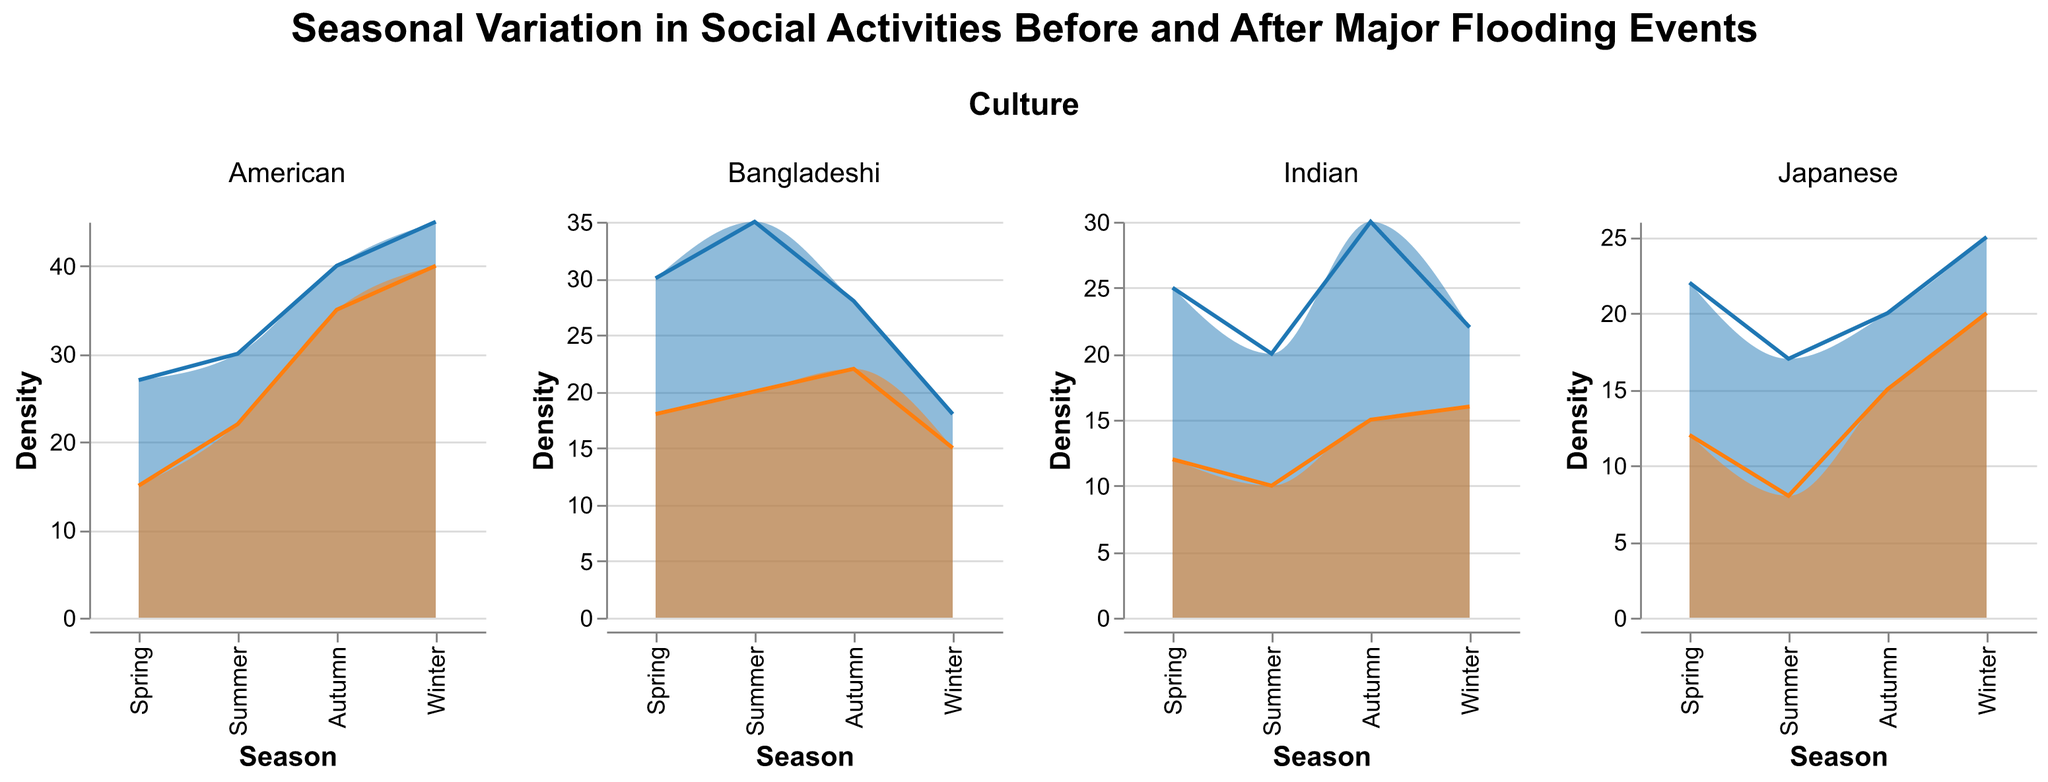What is the title of the figure? The title is displayed at the top of the figure in large font. It reads "Seasonal Variation in Social Activities Before and After Major Flooding Events"
Answer: Seasonal Variation in Social Activities Before and After Major Flooding Events How many cultures are analyzed in the figure? The figure is divided into columns, each representing a different culture. There are four columns: Japanese, Bangladeshi, American, and Indian
Answer: Four What are the colors used to represent the pre-flood and post-flood activities? The density plots use two distinct colors: blue for pre-flood activities and orange for post-flood activities
Answer: Blue and orange Which season had the highest pre-flood activity for the American culture? By viewing the density lines for seasonal activities in the American culture, we can see that the highest pre-flood activity occurs in winter for Christmas
Answer: Winter What is the difference in post-flood density between the Japanese and Bangladeshi cultures for their spring activities? For spring activities, the post-flood densities are 12 for Japanese and 18 for Bangladeshi. The difference is 18 - 12
Answer: 6 In which season did the Indian culture experience the least decrease in activity post-flood compared to pre-flood? By comparing pre-flood and post-flood densities across seasons for the Indian culture, the smallest decrease is observed in Winter from 22 to 16
Answer: Winter What is the average pre-flood density of activities for the Japanese culture in spring and summer? The pre-flood densities for spring and summer for the Japanese culture are 22 and 17. The average is (22 + 17) / 2
Answer: 19.5 Which culture experienced the smallest overall change in social activities density after flooding during the autumn season? By examining the pre-flood and post-flood densities for autumn across all cultures, the American culture shows the smallest change from 40 to 35
Answer: American Which activity saw the largest decline in density post-flood in the Bangladeshi culture? Examining each activity density change in the Bangladeshi culture, Eid-ul-Fitr shows the largest decline from 35 to 20
Answer: Eid-ul-Fitr How does the post-flood density during winter solstice celebrations compare between American and Bangladeshi cultures? For winter solstice (Christmas for American and Winter Solstice Celebration for Bangladeshi), the post-flood densities are 40 for American and 15 for Bangladeshi
Answer: American culture is higher 